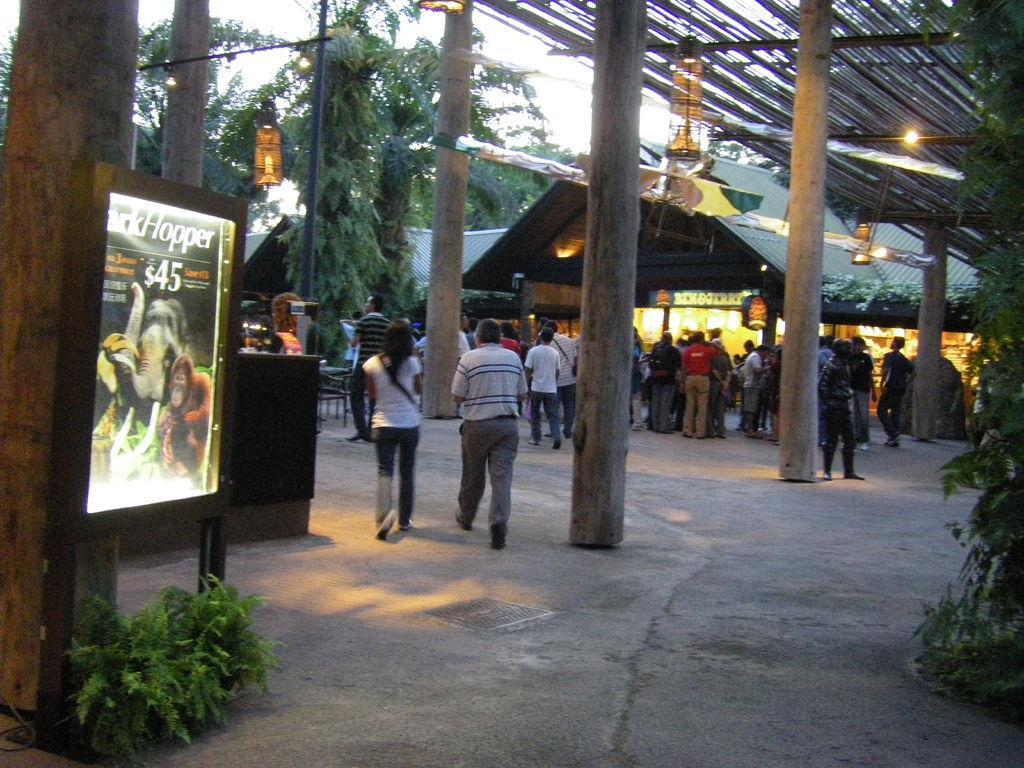Could you give a brief overview of what you see in this image? There are groups of people standing and few people walking. These look like the wooden pillars. I can see the lamps hanging. This looks like a shop with a name board. I can see a board, which is attached to the poles. These are the trees and small plants. 